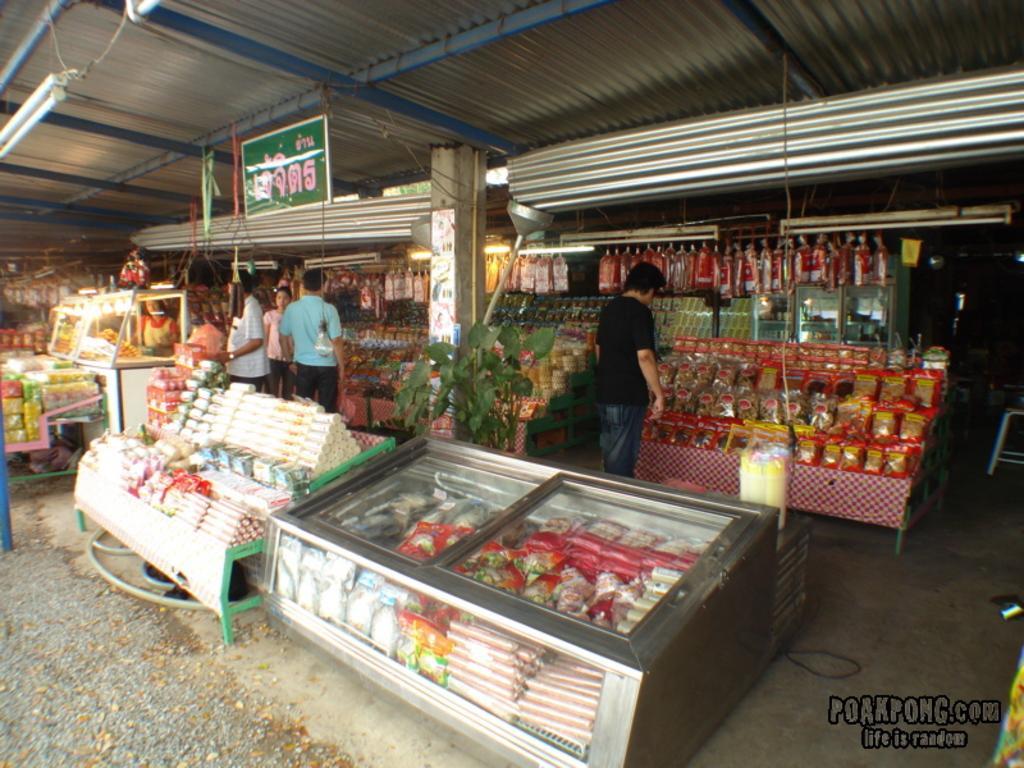Can you describe this image briefly? In this image, there are few people standing. I think these are the stores. I can see the things, which are arranged in an order and placed on the tables. These are the tube lights. I think this is a rolling shutter. I can see a name board hanging. At the bottom of the image, that looks like the watermark. 